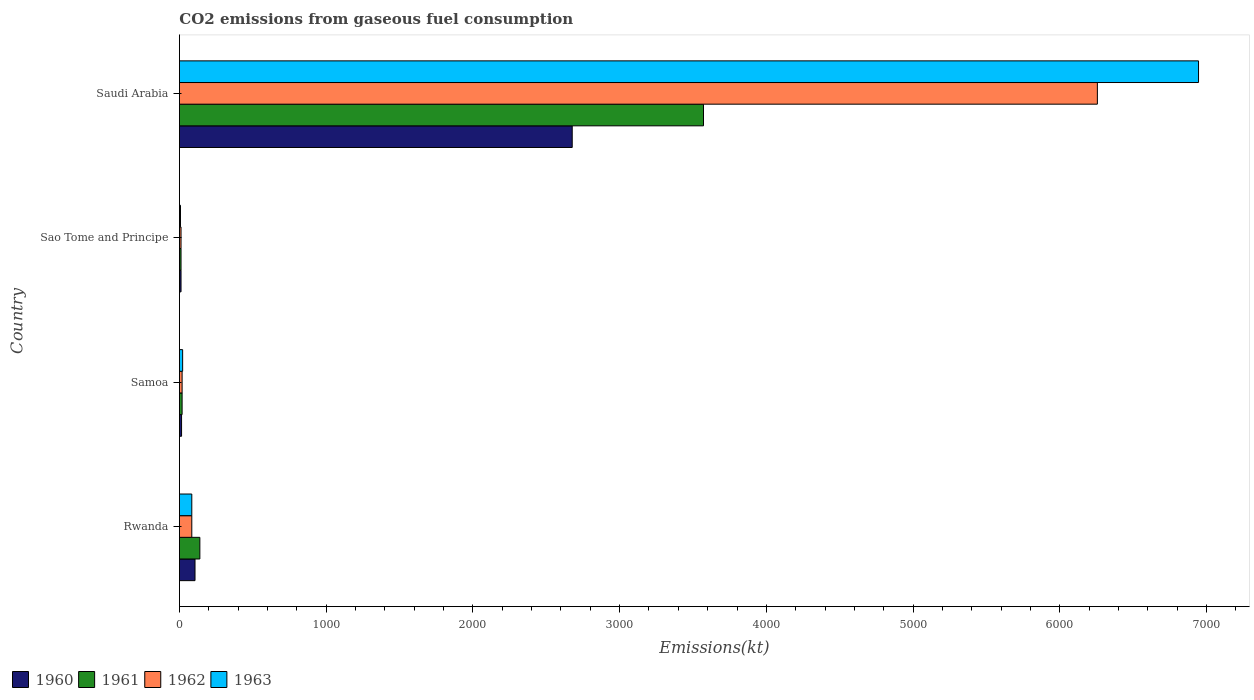How many different coloured bars are there?
Provide a short and direct response. 4. How many groups of bars are there?
Keep it short and to the point. 4. How many bars are there on the 3rd tick from the top?
Your answer should be compact. 4. How many bars are there on the 2nd tick from the bottom?
Your answer should be compact. 4. What is the label of the 1st group of bars from the top?
Your response must be concise. Saudi Arabia. What is the amount of CO2 emitted in 1963 in Rwanda?
Your response must be concise. 84.34. Across all countries, what is the maximum amount of CO2 emitted in 1962?
Keep it short and to the point. 6255.9. Across all countries, what is the minimum amount of CO2 emitted in 1963?
Your response must be concise. 7.33. In which country was the amount of CO2 emitted in 1961 maximum?
Your answer should be very brief. Saudi Arabia. In which country was the amount of CO2 emitted in 1960 minimum?
Offer a very short reply. Sao Tome and Principe. What is the total amount of CO2 emitted in 1961 in the graph?
Offer a terse response. 3740.34. What is the difference between the amount of CO2 emitted in 1961 in Rwanda and that in Saudi Arabia?
Offer a very short reply. -3432.31. What is the difference between the amount of CO2 emitted in 1963 in Samoa and the amount of CO2 emitted in 1962 in Saudi Arabia?
Your answer should be very brief. -6233.9. What is the average amount of CO2 emitted in 1963 per country?
Provide a short and direct response. 1764.74. What is the difference between the amount of CO2 emitted in 1961 and amount of CO2 emitted in 1963 in Sao Tome and Principe?
Ensure brevity in your answer.  3.67. What is the ratio of the amount of CO2 emitted in 1961 in Rwanda to that in Sao Tome and Principe?
Provide a succinct answer. 12.67. Is the amount of CO2 emitted in 1961 in Sao Tome and Principe less than that in Saudi Arabia?
Keep it short and to the point. Yes. What is the difference between the highest and the second highest amount of CO2 emitted in 1961?
Your answer should be compact. 3432.31. What is the difference between the highest and the lowest amount of CO2 emitted in 1961?
Your answer should be compact. 3560.66. In how many countries, is the amount of CO2 emitted in 1961 greater than the average amount of CO2 emitted in 1961 taken over all countries?
Ensure brevity in your answer.  1. Is the sum of the amount of CO2 emitted in 1962 in Sao Tome and Principe and Saudi Arabia greater than the maximum amount of CO2 emitted in 1963 across all countries?
Make the answer very short. No. Is it the case that in every country, the sum of the amount of CO2 emitted in 1961 and amount of CO2 emitted in 1960 is greater than the sum of amount of CO2 emitted in 1962 and amount of CO2 emitted in 1963?
Give a very brief answer. No. What does the 3rd bar from the top in Sao Tome and Principe represents?
Ensure brevity in your answer.  1961. What does the 2nd bar from the bottom in Samoa represents?
Your answer should be compact. 1961. Is it the case that in every country, the sum of the amount of CO2 emitted in 1960 and amount of CO2 emitted in 1963 is greater than the amount of CO2 emitted in 1962?
Make the answer very short. Yes. How many countries are there in the graph?
Keep it short and to the point. 4. What is the difference between two consecutive major ticks on the X-axis?
Provide a short and direct response. 1000. Are the values on the major ticks of X-axis written in scientific E-notation?
Your response must be concise. No. Does the graph contain any zero values?
Offer a very short reply. No. How many legend labels are there?
Your response must be concise. 4. How are the legend labels stacked?
Offer a terse response. Horizontal. What is the title of the graph?
Keep it short and to the point. CO2 emissions from gaseous fuel consumption. What is the label or title of the X-axis?
Ensure brevity in your answer.  Emissions(kt). What is the Emissions(kt) of 1960 in Rwanda?
Offer a very short reply. 106.34. What is the Emissions(kt) of 1961 in Rwanda?
Make the answer very short. 139.35. What is the Emissions(kt) in 1962 in Rwanda?
Provide a succinct answer. 84.34. What is the Emissions(kt) of 1963 in Rwanda?
Give a very brief answer. 84.34. What is the Emissions(kt) in 1960 in Samoa?
Keep it short and to the point. 14.67. What is the Emissions(kt) in 1961 in Samoa?
Your answer should be very brief. 18.34. What is the Emissions(kt) of 1962 in Samoa?
Make the answer very short. 18.34. What is the Emissions(kt) in 1963 in Samoa?
Give a very brief answer. 22. What is the Emissions(kt) of 1960 in Sao Tome and Principe?
Provide a succinct answer. 11. What is the Emissions(kt) of 1961 in Sao Tome and Principe?
Ensure brevity in your answer.  11. What is the Emissions(kt) in 1962 in Sao Tome and Principe?
Provide a short and direct response. 11. What is the Emissions(kt) in 1963 in Sao Tome and Principe?
Make the answer very short. 7.33. What is the Emissions(kt) of 1960 in Saudi Arabia?
Your answer should be compact. 2676.91. What is the Emissions(kt) in 1961 in Saudi Arabia?
Provide a short and direct response. 3571.66. What is the Emissions(kt) in 1962 in Saudi Arabia?
Your answer should be compact. 6255.9. What is the Emissions(kt) of 1963 in Saudi Arabia?
Your answer should be very brief. 6945.3. Across all countries, what is the maximum Emissions(kt) in 1960?
Offer a terse response. 2676.91. Across all countries, what is the maximum Emissions(kt) of 1961?
Ensure brevity in your answer.  3571.66. Across all countries, what is the maximum Emissions(kt) in 1962?
Ensure brevity in your answer.  6255.9. Across all countries, what is the maximum Emissions(kt) in 1963?
Your answer should be very brief. 6945.3. Across all countries, what is the minimum Emissions(kt) in 1960?
Offer a very short reply. 11. Across all countries, what is the minimum Emissions(kt) of 1961?
Make the answer very short. 11. Across all countries, what is the minimum Emissions(kt) in 1962?
Give a very brief answer. 11. Across all countries, what is the minimum Emissions(kt) of 1963?
Provide a short and direct response. 7.33. What is the total Emissions(kt) of 1960 in the graph?
Make the answer very short. 2808.92. What is the total Emissions(kt) in 1961 in the graph?
Provide a short and direct response. 3740.34. What is the total Emissions(kt) in 1962 in the graph?
Your answer should be compact. 6369.58. What is the total Emissions(kt) in 1963 in the graph?
Your answer should be compact. 7058.98. What is the difference between the Emissions(kt) of 1960 in Rwanda and that in Samoa?
Ensure brevity in your answer.  91.67. What is the difference between the Emissions(kt) in 1961 in Rwanda and that in Samoa?
Offer a terse response. 121.01. What is the difference between the Emissions(kt) in 1962 in Rwanda and that in Samoa?
Offer a very short reply. 66.01. What is the difference between the Emissions(kt) of 1963 in Rwanda and that in Samoa?
Provide a short and direct response. 62.34. What is the difference between the Emissions(kt) of 1960 in Rwanda and that in Sao Tome and Principe?
Provide a succinct answer. 95.34. What is the difference between the Emissions(kt) in 1961 in Rwanda and that in Sao Tome and Principe?
Keep it short and to the point. 128.34. What is the difference between the Emissions(kt) in 1962 in Rwanda and that in Sao Tome and Principe?
Provide a succinct answer. 73.34. What is the difference between the Emissions(kt) in 1963 in Rwanda and that in Sao Tome and Principe?
Offer a very short reply. 77.01. What is the difference between the Emissions(kt) in 1960 in Rwanda and that in Saudi Arabia?
Your answer should be very brief. -2570.57. What is the difference between the Emissions(kt) in 1961 in Rwanda and that in Saudi Arabia?
Provide a succinct answer. -3432.31. What is the difference between the Emissions(kt) in 1962 in Rwanda and that in Saudi Arabia?
Ensure brevity in your answer.  -6171.56. What is the difference between the Emissions(kt) in 1963 in Rwanda and that in Saudi Arabia?
Your answer should be compact. -6860.96. What is the difference between the Emissions(kt) of 1960 in Samoa and that in Sao Tome and Principe?
Provide a succinct answer. 3.67. What is the difference between the Emissions(kt) of 1961 in Samoa and that in Sao Tome and Principe?
Your response must be concise. 7.33. What is the difference between the Emissions(kt) of 1962 in Samoa and that in Sao Tome and Principe?
Make the answer very short. 7.33. What is the difference between the Emissions(kt) of 1963 in Samoa and that in Sao Tome and Principe?
Keep it short and to the point. 14.67. What is the difference between the Emissions(kt) in 1960 in Samoa and that in Saudi Arabia?
Your response must be concise. -2662.24. What is the difference between the Emissions(kt) of 1961 in Samoa and that in Saudi Arabia?
Keep it short and to the point. -3553.32. What is the difference between the Emissions(kt) in 1962 in Samoa and that in Saudi Arabia?
Your response must be concise. -6237.57. What is the difference between the Emissions(kt) of 1963 in Samoa and that in Saudi Arabia?
Ensure brevity in your answer.  -6923.3. What is the difference between the Emissions(kt) in 1960 in Sao Tome and Principe and that in Saudi Arabia?
Your answer should be very brief. -2665.91. What is the difference between the Emissions(kt) of 1961 in Sao Tome and Principe and that in Saudi Arabia?
Give a very brief answer. -3560.66. What is the difference between the Emissions(kt) of 1962 in Sao Tome and Principe and that in Saudi Arabia?
Your answer should be very brief. -6244.9. What is the difference between the Emissions(kt) of 1963 in Sao Tome and Principe and that in Saudi Arabia?
Offer a terse response. -6937.96. What is the difference between the Emissions(kt) of 1960 in Rwanda and the Emissions(kt) of 1961 in Samoa?
Your answer should be compact. 88.01. What is the difference between the Emissions(kt) of 1960 in Rwanda and the Emissions(kt) of 1962 in Samoa?
Your response must be concise. 88.01. What is the difference between the Emissions(kt) of 1960 in Rwanda and the Emissions(kt) of 1963 in Samoa?
Keep it short and to the point. 84.34. What is the difference between the Emissions(kt) of 1961 in Rwanda and the Emissions(kt) of 1962 in Samoa?
Your answer should be compact. 121.01. What is the difference between the Emissions(kt) in 1961 in Rwanda and the Emissions(kt) in 1963 in Samoa?
Keep it short and to the point. 117.34. What is the difference between the Emissions(kt) of 1962 in Rwanda and the Emissions(kt) of 1963 in Samoa?
Ensure brevity in your answer.  62.34. What is the difference between the Emissions(kt) in 1960 in Rwanda and the Emissions(kt) in 1961 in Sao Tome and Principe?
Your answer should be compact. 95.34. What is the difference between the Emissions(kt) of 1960 in Rwanda and the Emissions(kt) of 1962 in Sao Tome and Principe?
Make the answer very short. 95.34. What is the difference between the Emissions(kt) of 1960 in Rwanda and the Emissions(kt) of 1963 in Sao Tome and Principe?
Keep it short and to the point. 99.01. What is the difference between the Emissions(kt) of 1961 in Rwanda and the Emissions(kt) of 1962 in Sao Tome and Principe?
Your answer should be very brief. 128.34. What is the difference between the Emissions(kt) in 1961 in Rwanda and the Emissions(kt) in 1963 in Sao Tome and Principe?
Your answer should be compact. 132.01. What is the difference between the Emissions(kt) in 1962 in Rwanda and the Emissions(kt) in 1963 in Sao Tome and Principe?
Your answer should be compact. 77.01. What is the difference between the Emissions(kt) in 1960 in Rwanda and the Emissions(kt) in 1961 in Saudi Arabia?
Make the answer very short. -3465.32. What is the difference between the Emissions(kt) in 1960 in Rwanda and the Emissions(kt) in 1962 in Saudi Arabia?
Give a very brief answer. -6149.56. What is the difference between the Emissions(kt) in 1960 in Rwanda and the Emissions(kt) in 1963 in Saudi Arabia?
Your answer should be very brief. -6838.95. What is the difference between the Emissions(kt) in 1961 in Rwanda and the Emissions(kt) in 1962 in Saudi Arabia?
Offer a very short reply. -6116.56. What is the difference between the Emissions(kt) in 1961 in Rwanda and the Emissions(kt) in 1963 in Saudi Arabia?
Offer a very short reply. -6805.95. What is the difference between the Emissions(kt) of 1962 in Rwanda and the Emissions(kt) of 1963 in Saudi Arabia?
Ensure brevity in your answer.  -6860.96. What is the difference between the Emissions(kt) of 1960 in Samoa and the Emissions(kt) of 1961 in Sao Tome and Principe?
Give a very brief answer. 3.67. What is the difference between the Emissions(kt) of 1960 in Samoa and the Emissions(kt) of 1962 in Sao Tome and Principe?
Provide a short and direct response. 3.67. What is the difference between the Emissions(kt) in 1960 in Samoa and the Emissions(kt) in 1963 in Sao Tome and Principe?
Your response must be concise. 7.33. What is the difference between the Emissions(kt) in 1961 in Samoa and the Emissions(kt) in 1962 in Sao Tome and Principe?
Ensure brevity in your answer.  7.33. What is the difference between the Emissions(kt) of 1961 in Samoa and the Emissions(kt) of 1963 in Sao Tome and Principe?
Provide a succinct answer. 11. What is the difference between the Emissions(kt) in 1962 in Samoa and the Emissions(kt) in 1963 in Sao Tome and Principe?
Ensure brevity in your answer.  11. What is the difference between the Emissions(kt) of 1960 in Samoa and the Emissions(kt) of 1961 in Saudi Arabia?
Your response must be concise. -3556.99. What is the difference between the Emissions(kt) in 1960 in Samoa and the Emissions(kt) in 1962 in Saudi Arabia?
Give a very brief answer. -6241.23. What is the difference between the Emissions(kt) of 1960 in Samoa and the Emissions(kt) of 1963 in Saudi Arabia?
Your answer should be very brief. -6930.63. What is the difference between the Emissions(kt) in 1961 in Samoa and the Emissions(kt) in 1962 in Saudi Arabia?
Make the answer very short. -6237.57. What is the difference between the Emissions(kt) of 1961 in Samoa and the Emissions(kt) of 1963 in Saudi Arabia?
Your answer should be very brief. -6926.96. What is the difference between the Emissions(kt) in 1962 in Samoa and the Emissions(kt) in 1963 in Saudi Arabia?
Your answer should be compact. -6926.96. What is the difference between the Emissions(kt) in 1960 in Sao Tome and Principe and the Emissions(kt) in 1961 in Saudi Arabia?
Ensure brevity in your answer.  -3560.66. What is the difference between the Emissions(kt) of 1960 in Sao Tome and Principe and the Emissions(kt) of 1962 in Saudi Arabia?
Ensure brevity in your answer.  -6244.9. What is the difference between the Emissions(kt) of 1960 in Sao Tome and Principe and the Emissions(kt) of 1963 in Saudi Arabia?
Your response must be concise. -6934.3. What is the difference between the Emissions(kt) in 1961 in Sao Tome and Principe and the Emissions(kt) in 1962 in Saudi Arabia?
Offer a very short reply. -6244.9. What is the difference between the Emissions(kt) of 1961 in Sao Tome and Principe and the Emissions(kt) of 1963 in Saudi Arabia?
Offer a very short reply. -6934.3. What is the difference between the Emissions(kt) of 1962 in Sao Tome and Principe and the Emissions(kt) of 1963 in Saudi Arabia?
Your answer should be very brief. -6934.3. What is the average Emissions(kt) in 1960 per country?
Give a very brief answer. 702.23. What is the average Emissions(kt) in 1961 per country?
Provide a succinct answer. 935.09. What is the average Emissions(kt) of 1962 per country?
Offer a terse response. 1592.39. What is the average Emissions(kt) of 1963 per country?
Your response must be concise. 1764.74. What is the difference between the Emissions(kt) of 1960 and Emissions(kt) of 1961 in Rwanda?
Give a very brief answer. -33. What is the difference between the Emissions(kt) of 1960 and Emissions(kt) of 1962 in Rwanda?
Make the answer very short. 22. What is the difference between the Emissions(kt) in 1960 and Emissions(kt) in 1963 in Rwanda?
Provide a succinct answer. 22. What is the difference between the Emissions(kt) in 1961 and Emissions(kt) in 1962 in Rwanda?
Your answer should be compact. 55.01. What is the difference between the Emissions(kt) in 1961 and Emissions(kt) in 1963 in Rwanda?
Ensure brevity in your answer.  55.01. What is the difference between the Emissions(kt) of 1962 and Emissions(kt) of 1963 in Rwanda?
Provide a succinct answer. 0. What is the difference between the Emissions(kt) in 1960 and Emissions(kt) in 1961 in Samoa?
Keep it short and to the point. -3.67. What is the difference between the Emissions(kt) of 1960 and Emissions(kt) of 1962 in Samoa?
Provide a succinct answer. -3.67. What is the difference between the Emissions(kt) of 1960 and Emissions(kt) of 1963 in Samoa?
Your response must be concise. -7.33. What is the difference between the Emissions(kt) of 1961 and Emissions(kt) of 1962 in Samoa?
Offer a terse response. 0. What is the difference between the Emissions(kt) in 1961 and Emissions(kt) in 1963 in Samoa?
Ensure brevity in your answer.  -3.67. What is the difference between the Emissions(kt) of 1962 and Emissions(kt) of 1963 in Samoa?
Offer a very short reply. -3.67. What is the difference between the Emissions(kt) in 1960 and Emissions(kt) in 1962 in Sao Tome and Principe?
Keep it short and to the point. 0. What is the difference between the Emissions(kt) in 1960 and Emissions(kt) in 1963 in Sao Tome and Principe?
Your response must be concise. 3.67. What is the difference between the Emissions(kt) of 1961 and Emissions(kt) of 1963 in Sao Tome and Principe?
Ensure brevity in your answer.  3.67. What is the difference between the Emissions(kt) in 1962 and Emissions(kt) in 1963 in Sao Tome and Principe?
Make the answer very short. 3.67. What is the difference between the Emissions(kt) of 1960 and Emissions(kt) of 1961 in Saudi Arabia?
Offer a very short reply. -894.75. What is the difference between the Emissions(kt) of 1960 and Emissions(kt) of 1962 in Saudi Arabia?
Provide a succinct answer. -3578.99. What is the difference between the Emissions(kt) of 1960 and Emissions(kt) of 1963 in Saudi Arabia?
Give a very brief answer. -4268.39. What is the difference between the Emissions(kt) in 1961 and Emissions(kt) in 1962 in Saudi Arabia?
Offer a very short reply. -2684.24. What is the difference between the Emissions(kt) in 1961 and Emissions(kt) in 1963 in Saudi Arabia?
Make the answer very short. -3373.64. What is the difference between the Emissions(kt) in 1962 and Emissions(kt) in 1963 in Saudi Arabia?
Make the answer very short. -689.4. What is the ratio of the Emissions(kt) in 1960 in Rwanda to that in Samoa?
Make the answer very short. 7.25. What is the ratio of the Emissions(kt) in 1961 in Rwanda to that in Samoa?
Your answer should be very brief. 7.6. What is the ratio of the Emissions(kt) in 1963 in Rwanda to that in Samoa?
Give a very brief answer. 3.83. What is the ratio of the Emissions(kt) of 1960 in Rwanda to that in Sao Tome and Principe?
Provide a short and direct response. 9.67. What is the ratio of the Emissions(kt) in 1961 in Rwanda to that in Sao Tome and Principe?
Ensure brevity in your answer.  12.67. What is the ratio of the Emissions(kt) of 1962 in Rwanda to that in Sao Tome and Principe?
Your response must be concise. 7.67. What is the ratio of the Emissions(kt) in 1963 in Rwanda to that in Sao Tome and Principe?
Ensure brevity in your answer.  11.5. What is the ratio of the Emissions(kt) in 1960 in Rwanda to that in Saudi Arabia?
Keep it short and to the point. 0.04. What is the ratio of the Emissions(kt) in 1961 in Rwanda to that in Saudi Arabia?
Provide a succinct answer. 0.04. What is the ratio of the Emissions(kt) in 1962 in Rwanda to that in Saudi Arabia?
Offer a very short reply. 0.01. What is the ratio of the Emissions(kt) of 1963 in Rwanda to that in Saudi Arabia?
Provide a short and direct response. 0.01. What is the ratio of the Emissions(kt) of 1961 in Samoa to that in Sao Tome and Principe?
Offer a terse response. 1.67. What is the ratio of the Emissions(kt) of 1960 in Samoa to that in Saudi Arabia?
Your answer should be very brief. 0.01. What is the ratio of the Emissions(kt) in 1961 in Samoa to that in Saudi Arabia?
Your answer should be very brief. 0.01. What is the ratio of the Emissions(kt) in 1962 in Samoa to that in Saudi Arabia?
Your answer should be compact. 0. What is the ratio of the Emissions(kt) of 1963 in Samoa to that in Saudi Arabia?
Your response must be concise. 0. What is the ratio of the Emissions(kt) of 1960 in Sao Tome and Principe to that in Saudi Arabia?
Keep it short and to the point. 0. What is the ratio of the Emissions(kt) in 1961 in Sao Tome and Principe to that in Saudi Arabia?
Provide a succinct answer. 0. What is the ratio of the Emissions(kt) of 1962 in Sao Tome and Principe to that in Saudi Arabia?
Keep it short and to the point. 0. What is the ratio of the Emissions(kt) in 1963 in Sao Tome and Principe to that in Saudi Arabia?
Make the answer very short. 0. What is the difference between the highest and the second highest Emissions(kt) in 1960?
Provide a succinct answer. 2570.57. What is the difference between the highest and the second highest Emissions(kt) in 1961?
Ensure brevity in your answer.  3432.31. What is the difference between the highest and the second highest Emissions(kt) in 1962?
Offer a very short reply. 6171.56. What is the difference between the highest and the second highest Emissions(kt) of 1963?
Keep it short and to the point. 6860.96. What is the difference between the highest and the lowest Emissions(kt) in 1960?
Offer a terse response. 2665.91. What is the difference between the highest and the lowest Emissions(kt) in 1961?
Ensure brevity in your answer.  3560.66. What is the difference between the highest and the lowest Emissions(kt) in 1962?
Keep it short and to the point. 6244.9. What is the difference between the highest and the lowest Emissions(kt) in 1963?
Make the answer very short. 6937.96. 